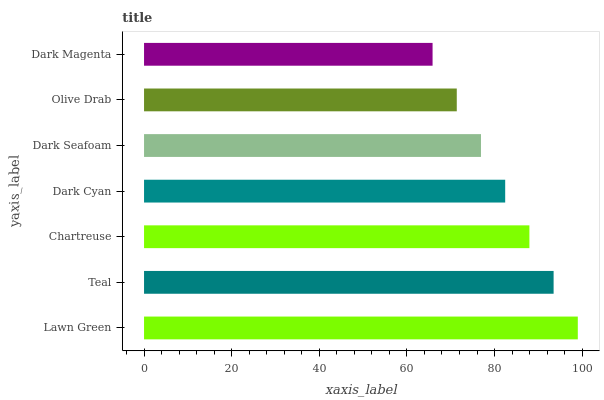Is Dark Magenta the minimum?
Answer yes or no. Yes. Is Lawn Green the maximum?
Answer yes or no. Yes. Is Teal the minimum?
Answer yes or no. No. Is Teal the maximum?
Answer yes or no. No. Is Lawn Green greater than Teal?
Answer yes or no. Yes. Is Teal less than Lawn Green?
Answer yes or no. Yes. Is Teal greater than Lawn Green?
Answer yes or no. No. Is Lawn Green less than Teal?
Answer yes or no. No. Is Dark Cyan the high median?
Answer yes or no. Yes. Is Dark Cyan the low median?
Answer yes or no. Yes. Is Olive Drab the high median?
Answer yes or no. No. Is Dark Magenta the low median?
Answer yes or no. No. 